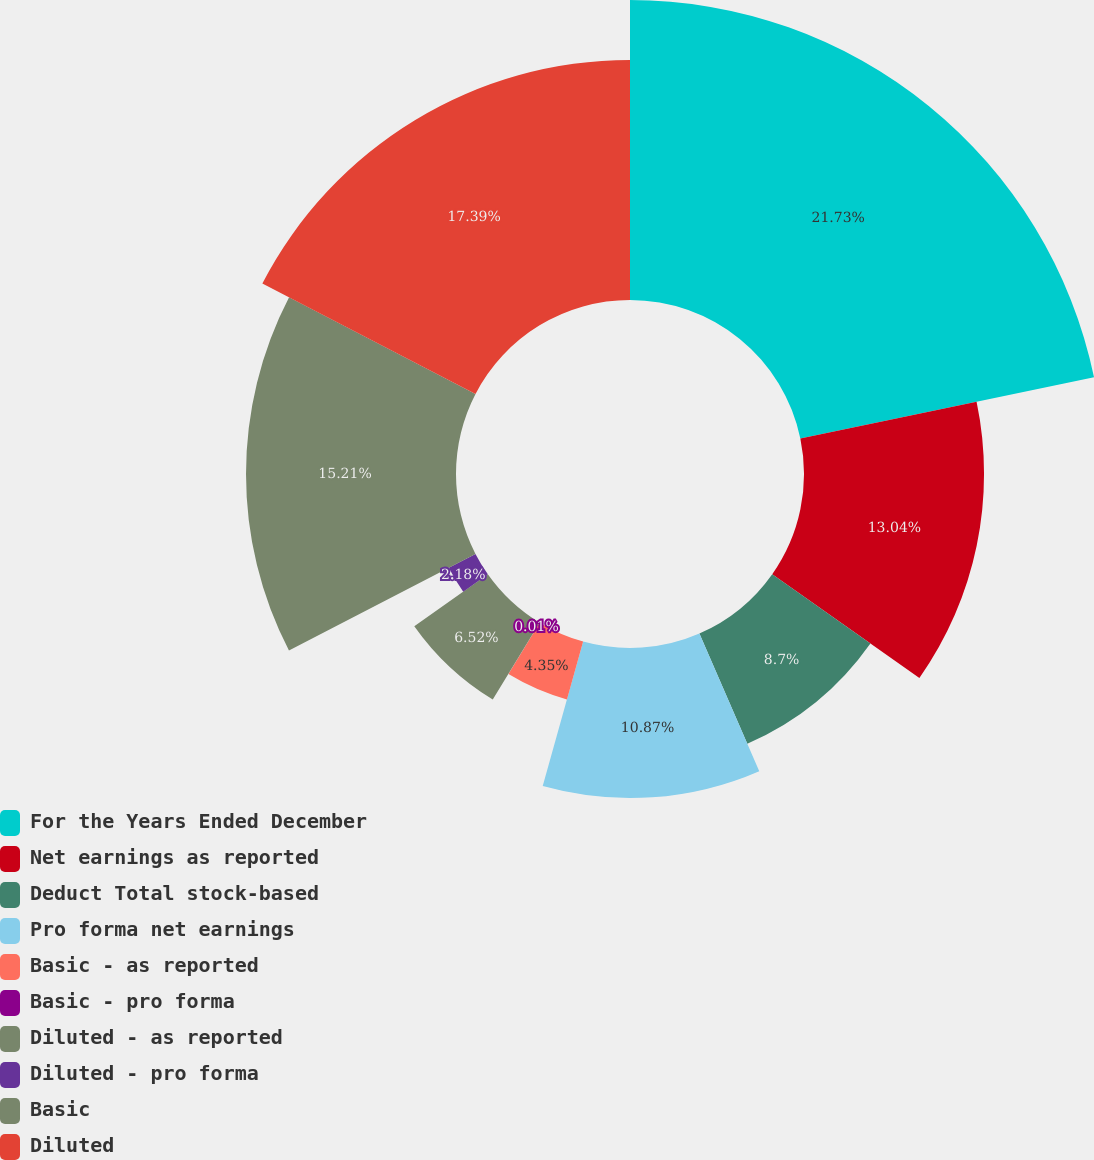Convert chart to OTSL. <chart><loc_0><loc_0><loc_500><loc_500><pie_chart><fcel>For the Years Ended December<fcel>Net earnings as reported<fcel>Deduct Total stock-based<fcel>Pro forma net earnings<fcel>Basic - as reported<fcel>Basic - pro forma<fcel>Diluted - as reported<fcel>Diluted - pro forma<fcel>Basic<fcel>Diluted<nl><fcel>21.73%<fcel>13.04%<fcel>8.7%<fcel>10.87%<fcel>4.35%<fcel>0.01%<fcel>6.52%<fcel>2.18%<fcel>15.21%<fcel>17.39%<nl></chart> 